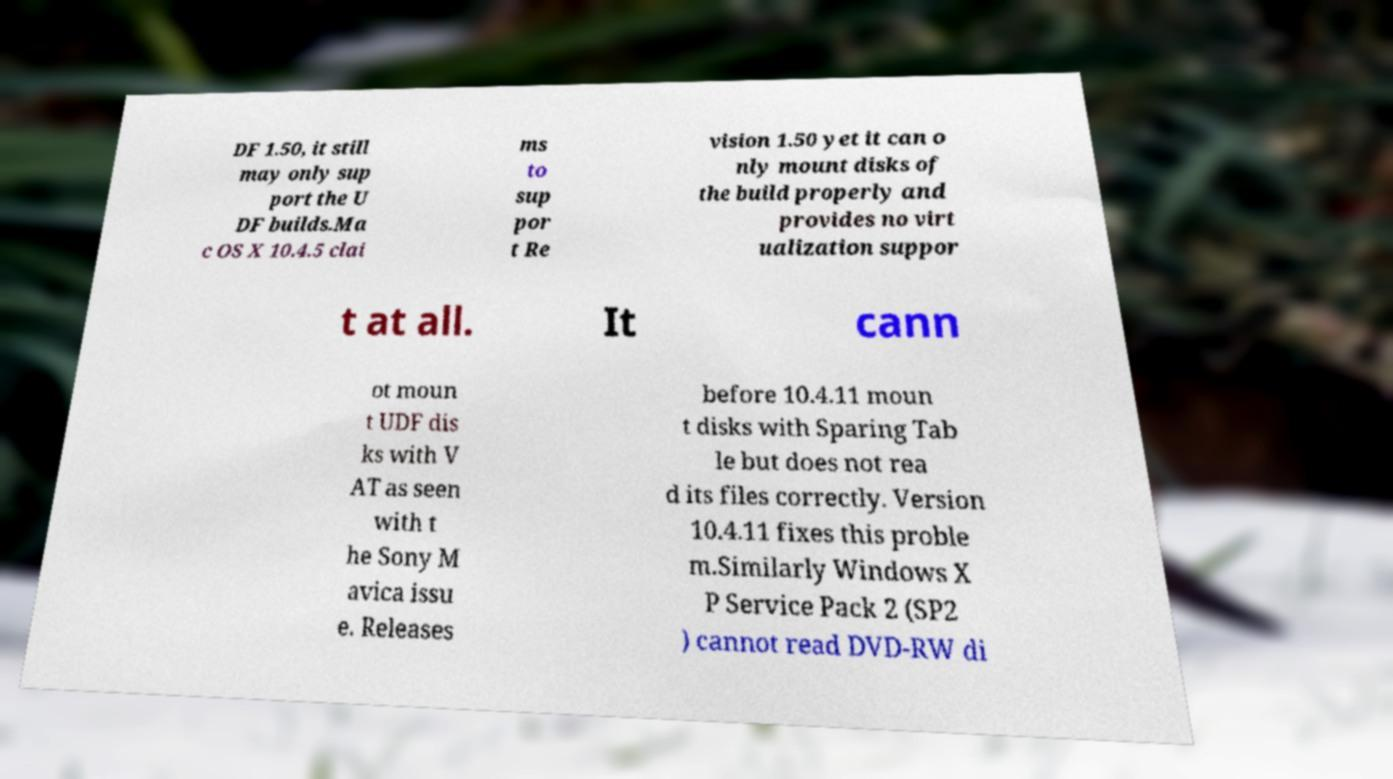Could you assist in decoding the text presented in this image and type it out clearly? DF 1.50, it still may only sup port the U DF builds.Ma c OS X 10.4.5 clai ms to sup por t Re vision 1.50 yet it can o nly mount disks of the build properly and provides no virt ualization suppor t at all. It cann ot moun t UDF dis ks with V AT as seen with t he Sony M avica issu e. Releases before 10.4.11 moun t disks with Sparing Tab le but does not rea d its files correctly. Version 10.4.11 fixes this proble m.Similarly Windows X P Service Pack 2 (SP2 ) cannot read DVD-RW di 